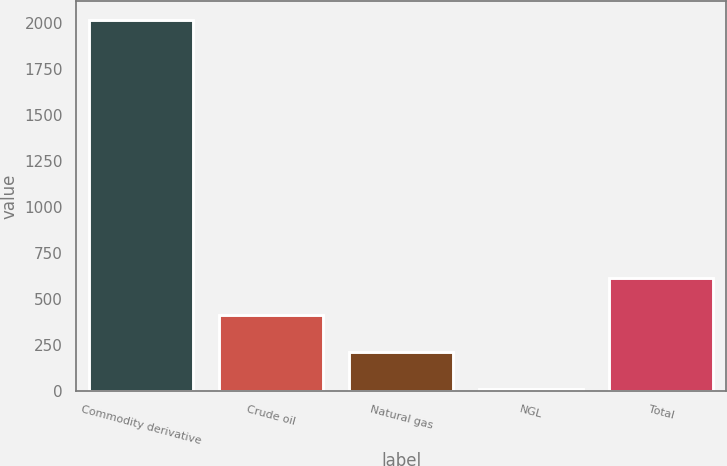<chart> <loc_0><loc_0><loc_500><loc_500><bar_chart><fcel>Commodity derivative<fcel>Crude oil<fcel>Natural gas<fcel>NGL<fcel>Total<nl><fcel>2017<fcel>411.4<fcel>210.7<fcel>10<fcel>612.1<nl></chart> 